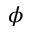Convert formula to latex. <formula><loc_0><loc_0><loc_500><loc_500>\phi</formula> 